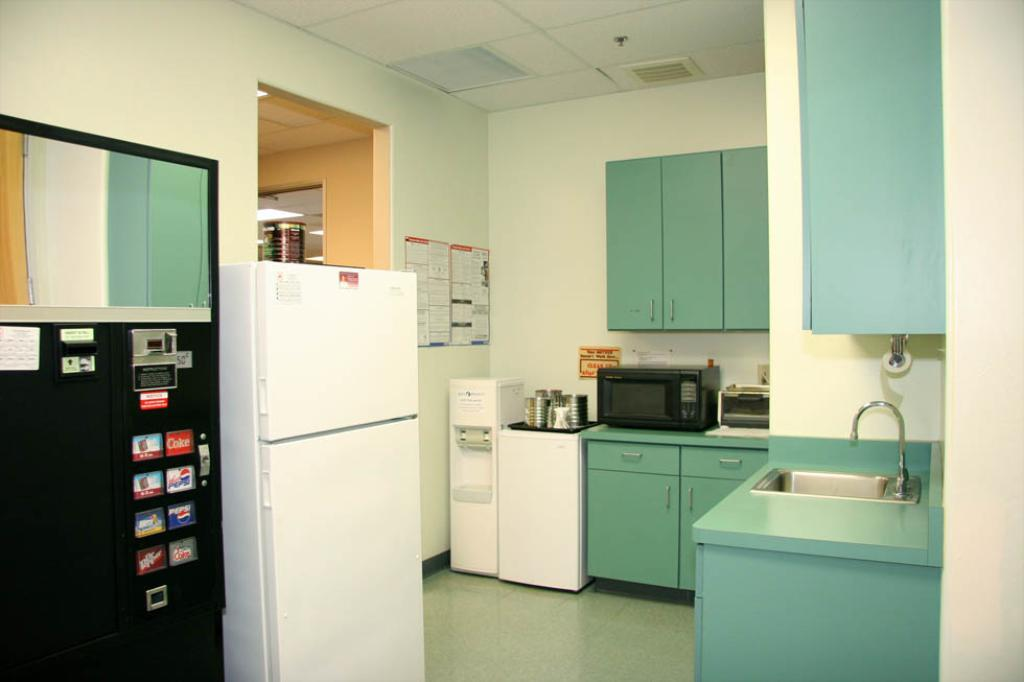<image>
Write a terse but informative summary of the picture. A break room in an office with a vending machine thar sells coke. 